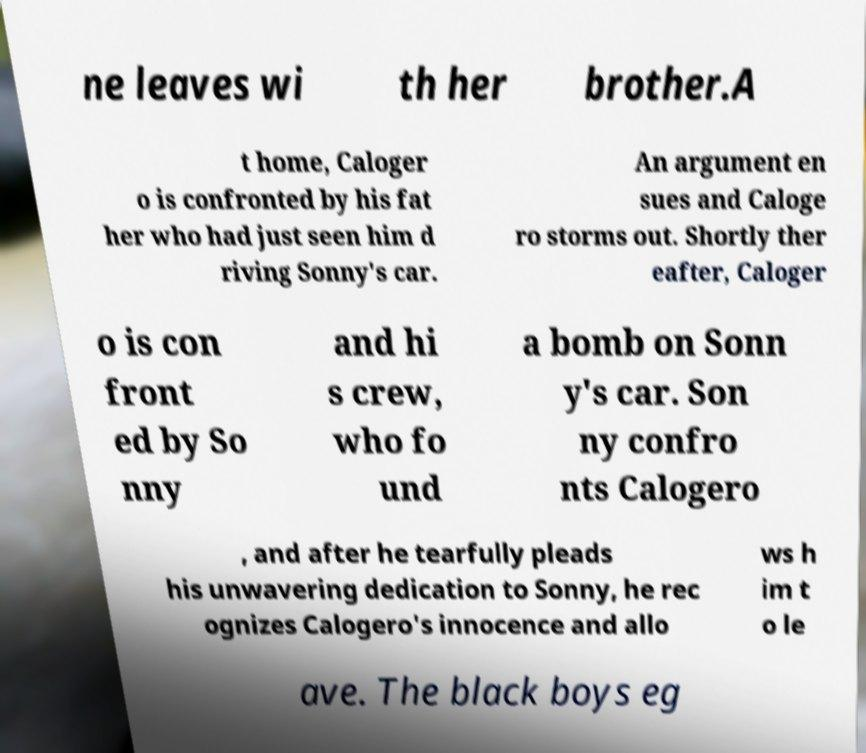Could you extract and type out the text from this image? ne leaves wi th her brother.A t home, Caloger o is confronted by his fat her who had just seen him d riving Sonny's car. An argument en sues and Caloge ro storms out. Shortly ther eafter, Caloger o is con front ed by So nny and hi s crew, who fo und a bomb on Sonn y's car. Son ny confro nts Calogero , and after he tearfully pleads his unwavering dedication to Sonny, he rec ognizes Calogero's innocence and allo ws h im t o le ave. The black boys eg 